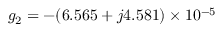<formula> <loc_0><loc_0><loc_500><loc_500>g _ { 2 } = - ( 6 . 5 6 5 + j 4 . 5 8 1 ) \times 1 0 ^ { - 5 }</formula> 